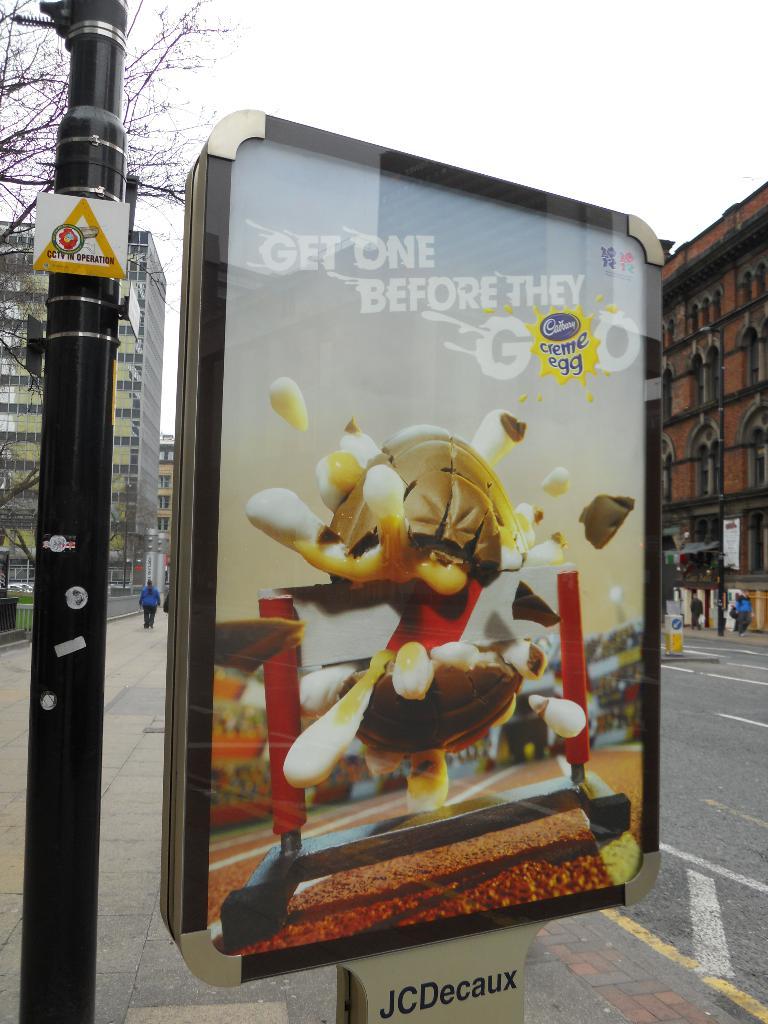What should you do before they go?
Make the answer very short. Get one. What company name is written on the bottom of the poster on the post?
Offer a terse response. Jcdecaux. 